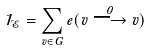<formula> <loc_0><loc_0><loc_500><loc_500>1 _ { \mathcal { E } } = \sum _ { v \in G } e ( v \stackrel { 0 } { \longrightarrow } v )</formula> 